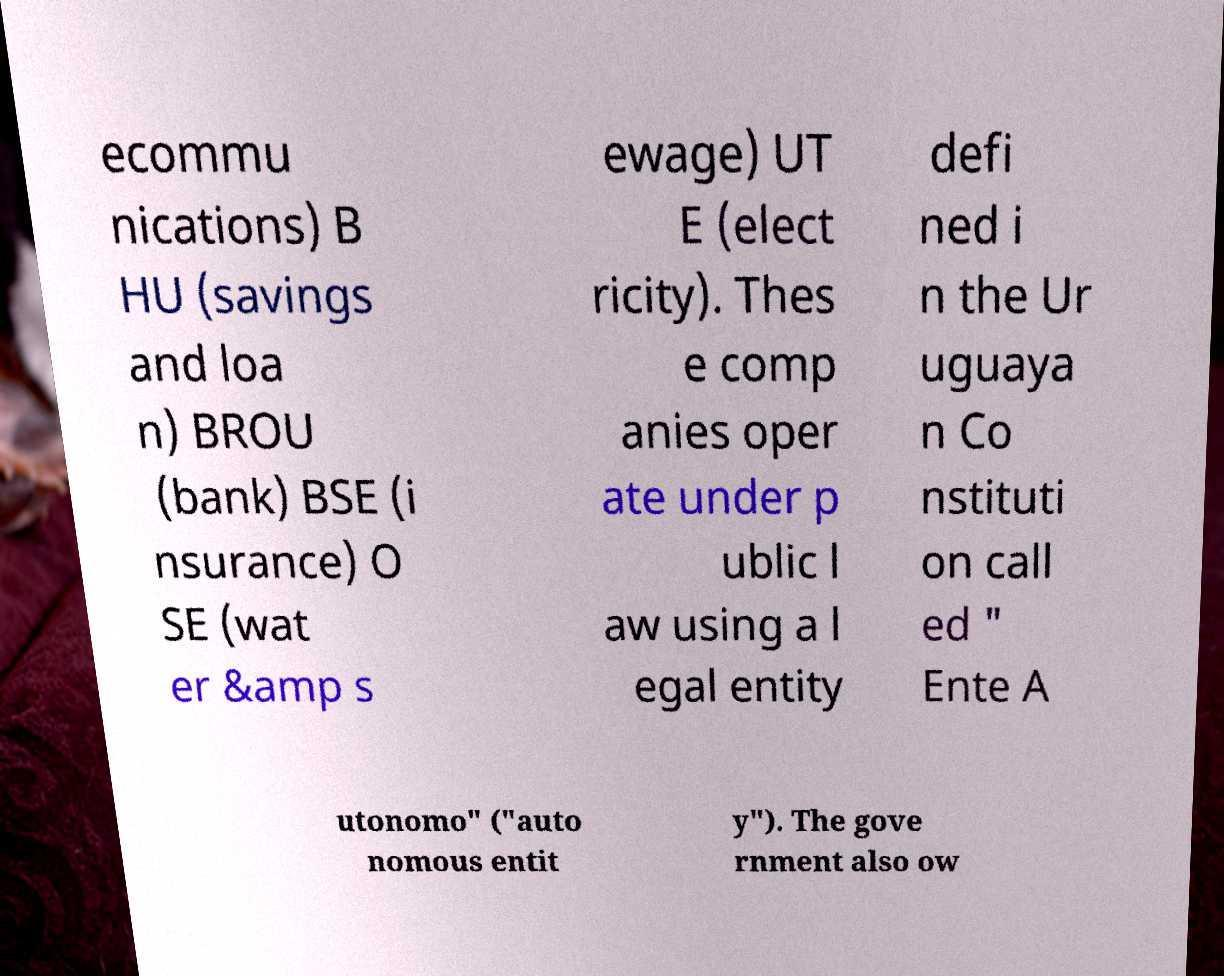For documentation purposes, I need the text within this image transcribed. Could you provide that? ecommu nications) B HU (savings and loa n) BROU (bank) BSE (i nsurance) O SE (wat er &amp s ewage) UT E (elect ricity). Thes e comp anies oper ate under p ublic l aw using a l egal entity defi ned i n the Ur uguaya n Co nstituti on call ed " Ente A utonomo" ("auto nomous entit y"). The gove rnment also ow 